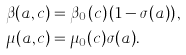<formula> <loc_0><loc_0><loc_500><loc_500>\beta ( a , c ) & = \beta _ { 0 } ( c ) \left ( 1 - \sigma ( a ) \right ) , \\ \mu ( a , c ) & = \mu _ { 0 } ( c ) \sigma ( a ) .</formula> 